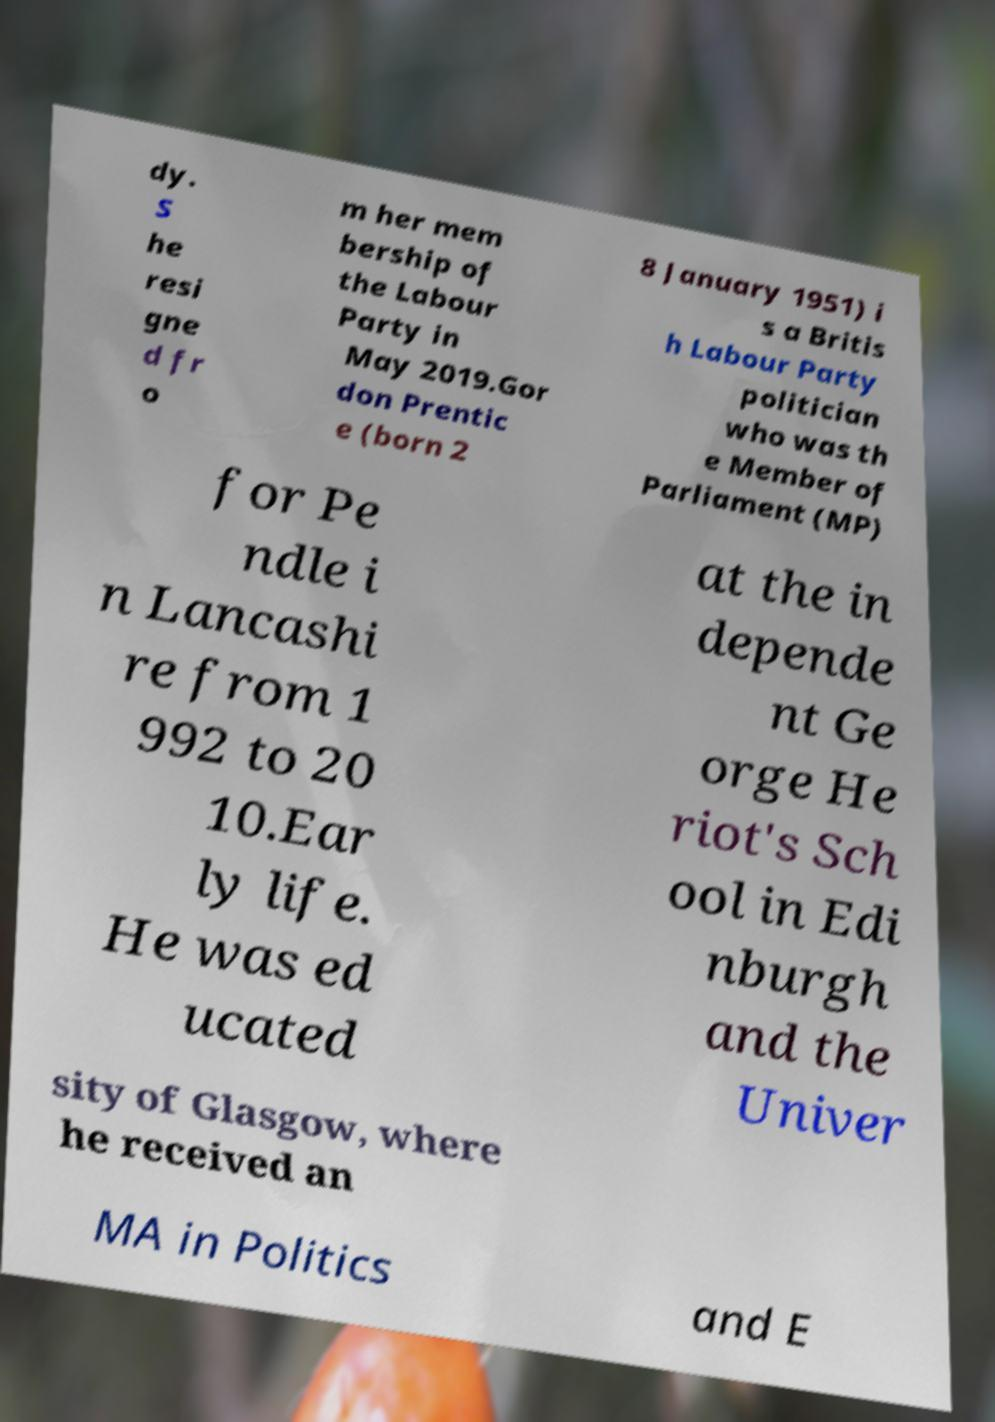I need the written content from this picture converted into text. Can you do that? dy. S he resi gne d fr o m her mem bership of the Labour Party in May 2019.Gor don Prentic e (born 2 8 January 1951) i s a Britis h Labour Party politician who was th e Member of Parliament (MP) for Pe ndle i n Lancashi re from 1 992 to 20 10.Ear ly life. He was ed ucated at the in depende nt Ge orge He riot's Sch ool in Edi nburgh and the Univer sity of Glasgow, where he received an MA in Politics and E 